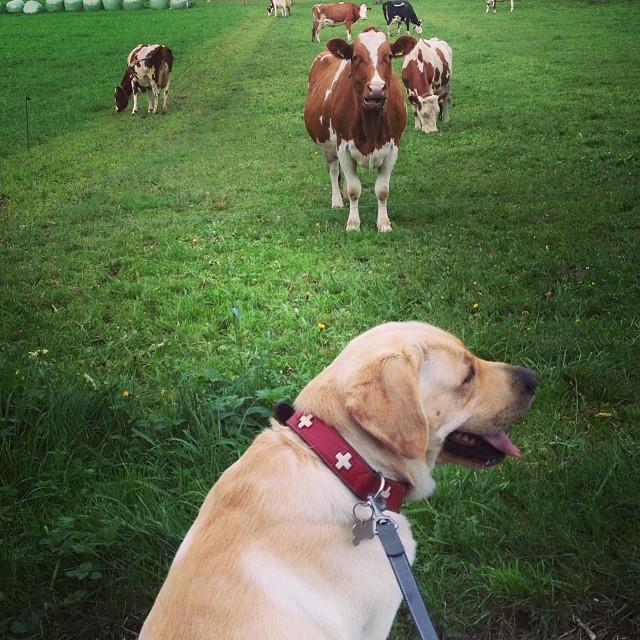How many cows are there?
Give a very brief answer. 3. 